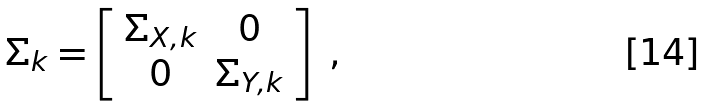<formula> <loc_0><loc_0><loc_500><loc_500>\Sigma _ { k } = \left [ \begin{array} { c c } \Sigma _ { X , k } & 0 \\ 0 & \Sigma _ { Y , k } \end{array} \right ] \text { ,}</formula> 